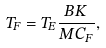<formula> <loc_0><loc_0><loc_500><loc_500>T _ { F } = T _ { E } \frac { B K } { M C _ { F } } ,</formula> 